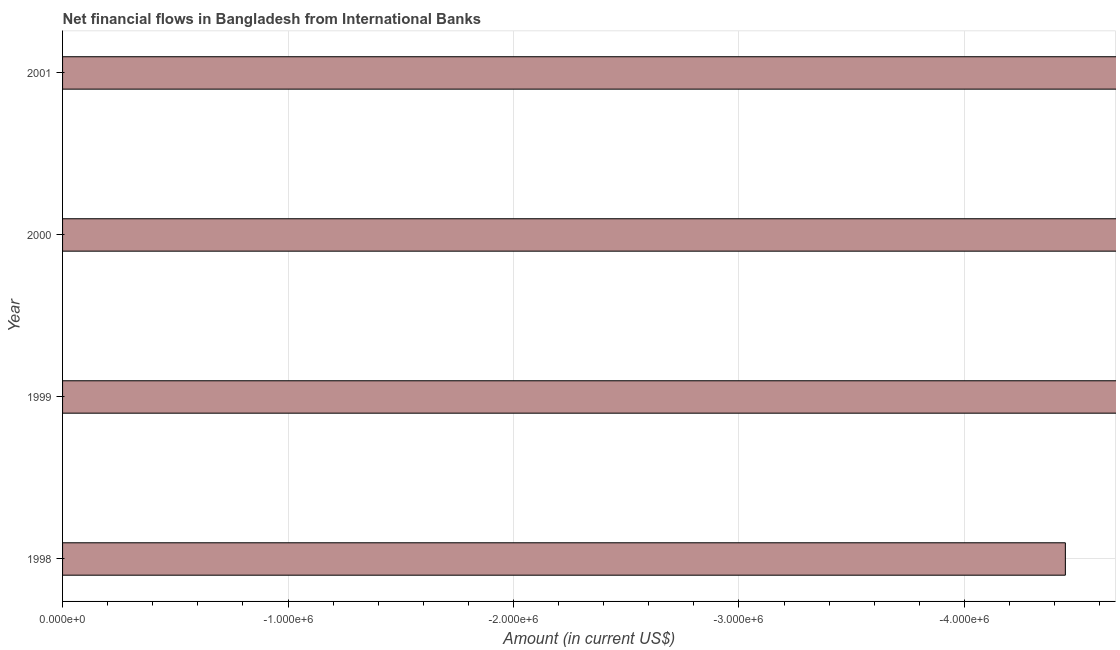What is the title of the graph?
Your answer should be very brief. Net financial flows in Bangladesh from International Banks. What is the label or title of the Y-axis?
Your response must be concise. Year. What is the net financial flows from ibrd in 1999?
Give a very brief answer. 0. Across all years, what is the minimum net financial flows from ibrd?
Your answer should be very brief. 0. In how many years, is the net financial flows from ibrd greater than -600000 US$?
Give a very brief answer. 0. How many bars are there?
Provide a succinct answer. 0. How many years are there in the graph?
Ensure brevity in your answer.  4. What is the Amount (in current US$) of 1999?
Offer a very short reply. 0. What is the Amount (in current US$) of 2001?
Your answer should be compact. 0. 